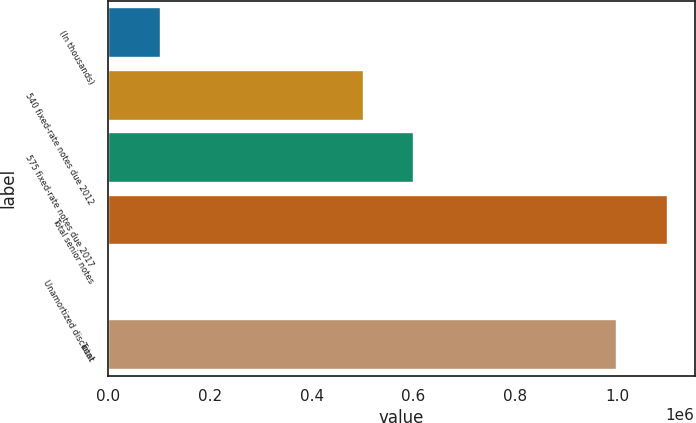<chart> <loc_0><loc_0><loc_500><loc_500><bar_chart><fcel>(In thousands)<fcel>540 fixed-rate notes due 2012<fcel>575 fixed-rate notes due 2017<fcel>Total senior notes<fcel>Unamortized discount<fcel>Total<nl><fcel>101634<fcel>500000<fcel>599818<fcel>1.098e+06<fcel>1816<fcel>998184<nl></chart> 